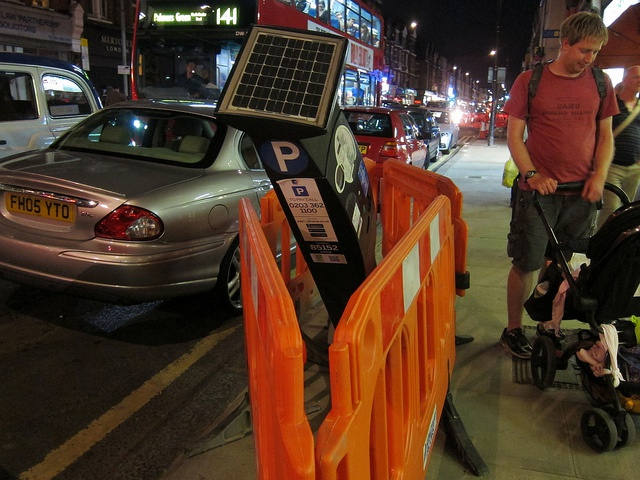Describe the objects in this image and their specific colors. I can see car in black, maroon, and gray tones, parking meter in black and gray tones, people in black, maroon, and brown tones, car in black, gray, and darkgray tones, and car in black, maroon, gray, and darkgray tones in this image. 